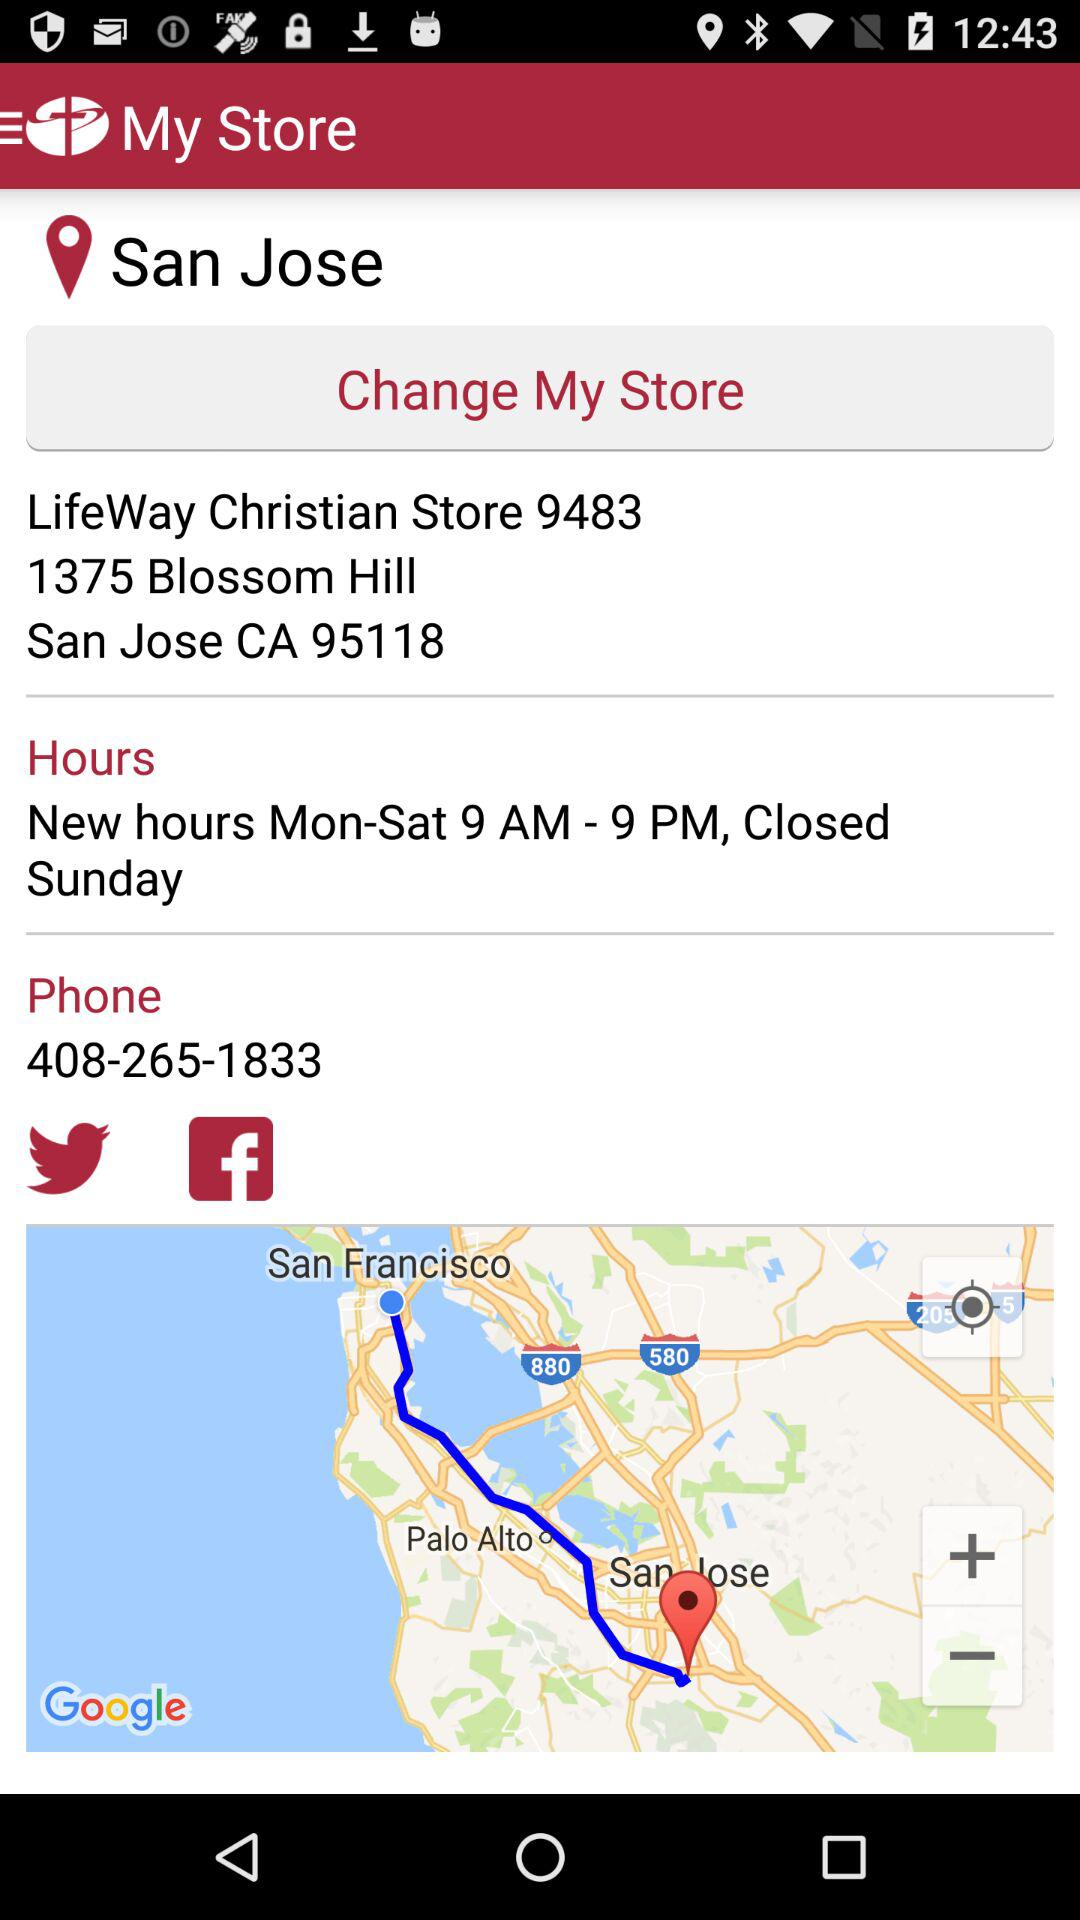What are the options available for sharing the location? The available options are "Twitter" and "Facebook". 